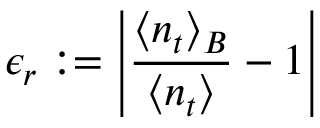<formula> <loc_0><loc_0><loc_500><loc_500>\epsilon _ { r } \colon = \left | \frac { \langle n _ { t } \rangle _ { B } } { \langle n _ { t } \rangle } - 1 \right |</formula> 